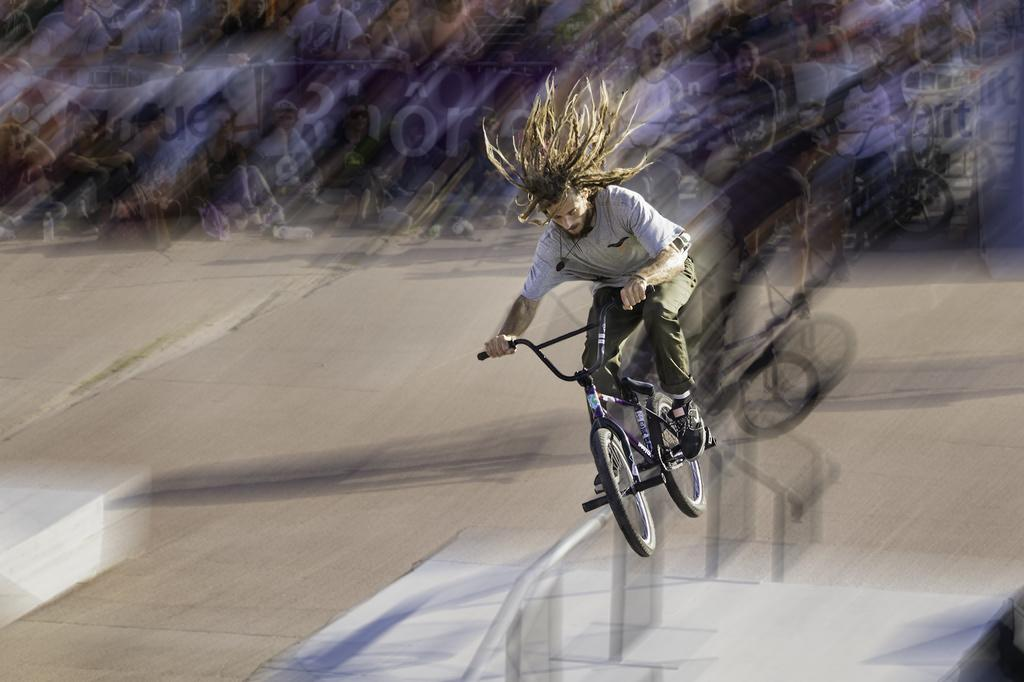What is the person in the image doing with the bicycle? The person is jumping with a bicycle in the image. How would you describe the quality of the image? The image is blurry. What else can be seen in the image besides the person jumping with a bicycle? There are people and bicycles visible at the top of the image. What type of throat problem is the person experiencing in the image? There is no indication of a throat problem in the image; the person is jumping with a bicycle. 